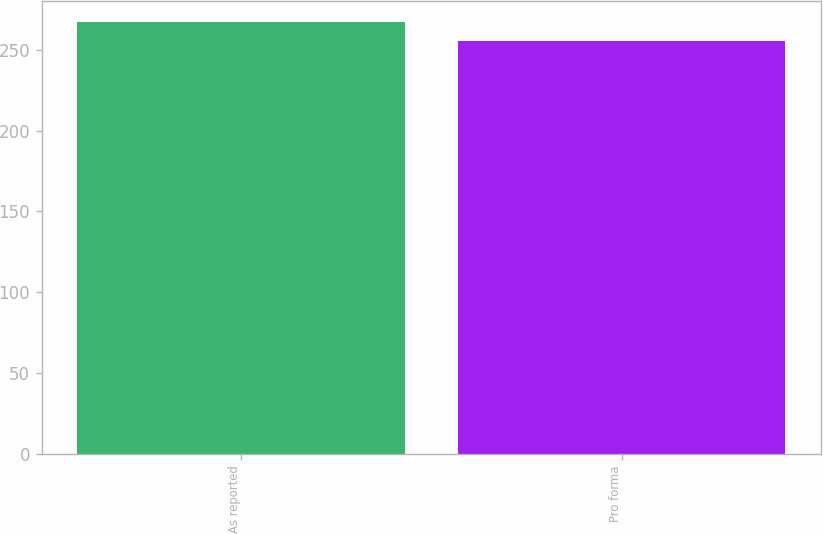Convert chart to OTSL. <chart><loc_0><loc_0><loc_500><loc_500><bar_chart><fcel>As reported<fcel>Pro forma<nl><fcel>267<fcel>255.2<nl></chart> 